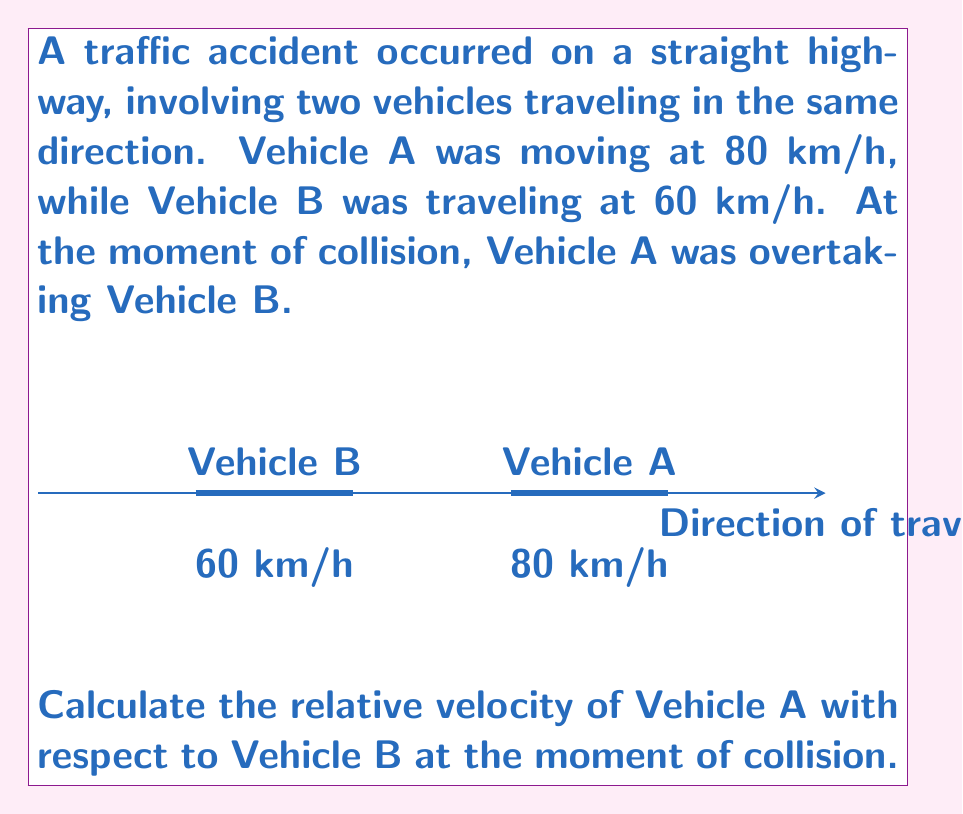Help me with this question. To solve this problem, we need to understand the concept of relative velocity. The relative velocity of one object with respect to another is the difference between their velocities.

Let's follow these steps:

1) Define the variables:
   $v_A$ = velocity of Vehicle A
   $v_B$ = velocity of Vehicle B

2) Given information:
   $v_A = 80$ km/h
   $v_B = 60$ km/h

3) The formula for relative velocity is:
   $$v_{rel} = v_A - v_B$$

   Where $v_{rel}$ is the relative velocity of A with respect to B.

4) Substitute the values:
   $$v_{rel} = 80 - 60$$

5) Calculate:
   $$v_{rel} = 20$$ km/h

The positive result indicates that Vehicle A is moving faster than Vehicle B, which aligns with the scenario of Vehicle A overtaking Vehicle B.

This relative velocity is crucial for analyzing the collision dynamics and can help in determining factors such as the impact force and the time available for evasive maneuvers.
Answer: $20$ km/h 